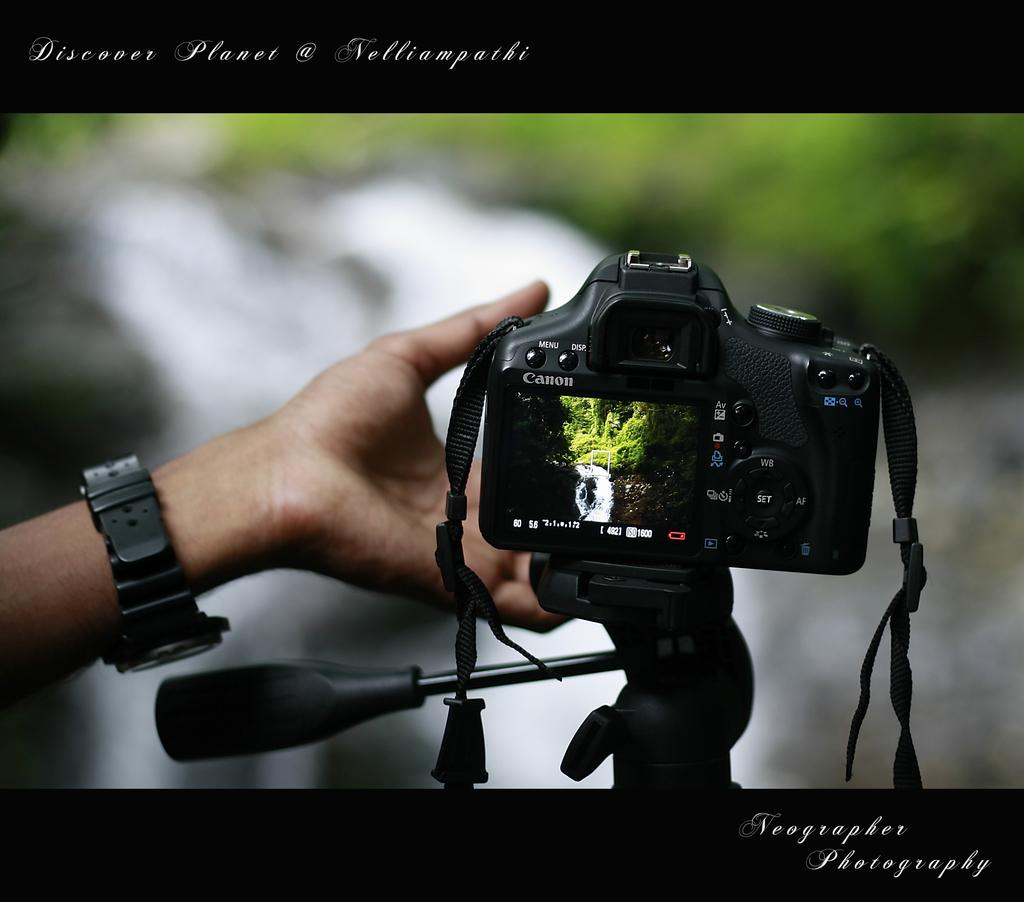<image>
Give a short and clear explanation of the subsequent image. Neographer Photography has taken a photo of a hand taking a photo. 